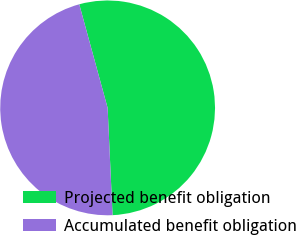<chart> <loc_0><loc_0><loc_500><loc_500><pie_chart><fcel>Projected benefit obligation<fcel>Accumulated benefit obligation<nl><fcel>53.52%<fcel>46.48%<nl></chart> 